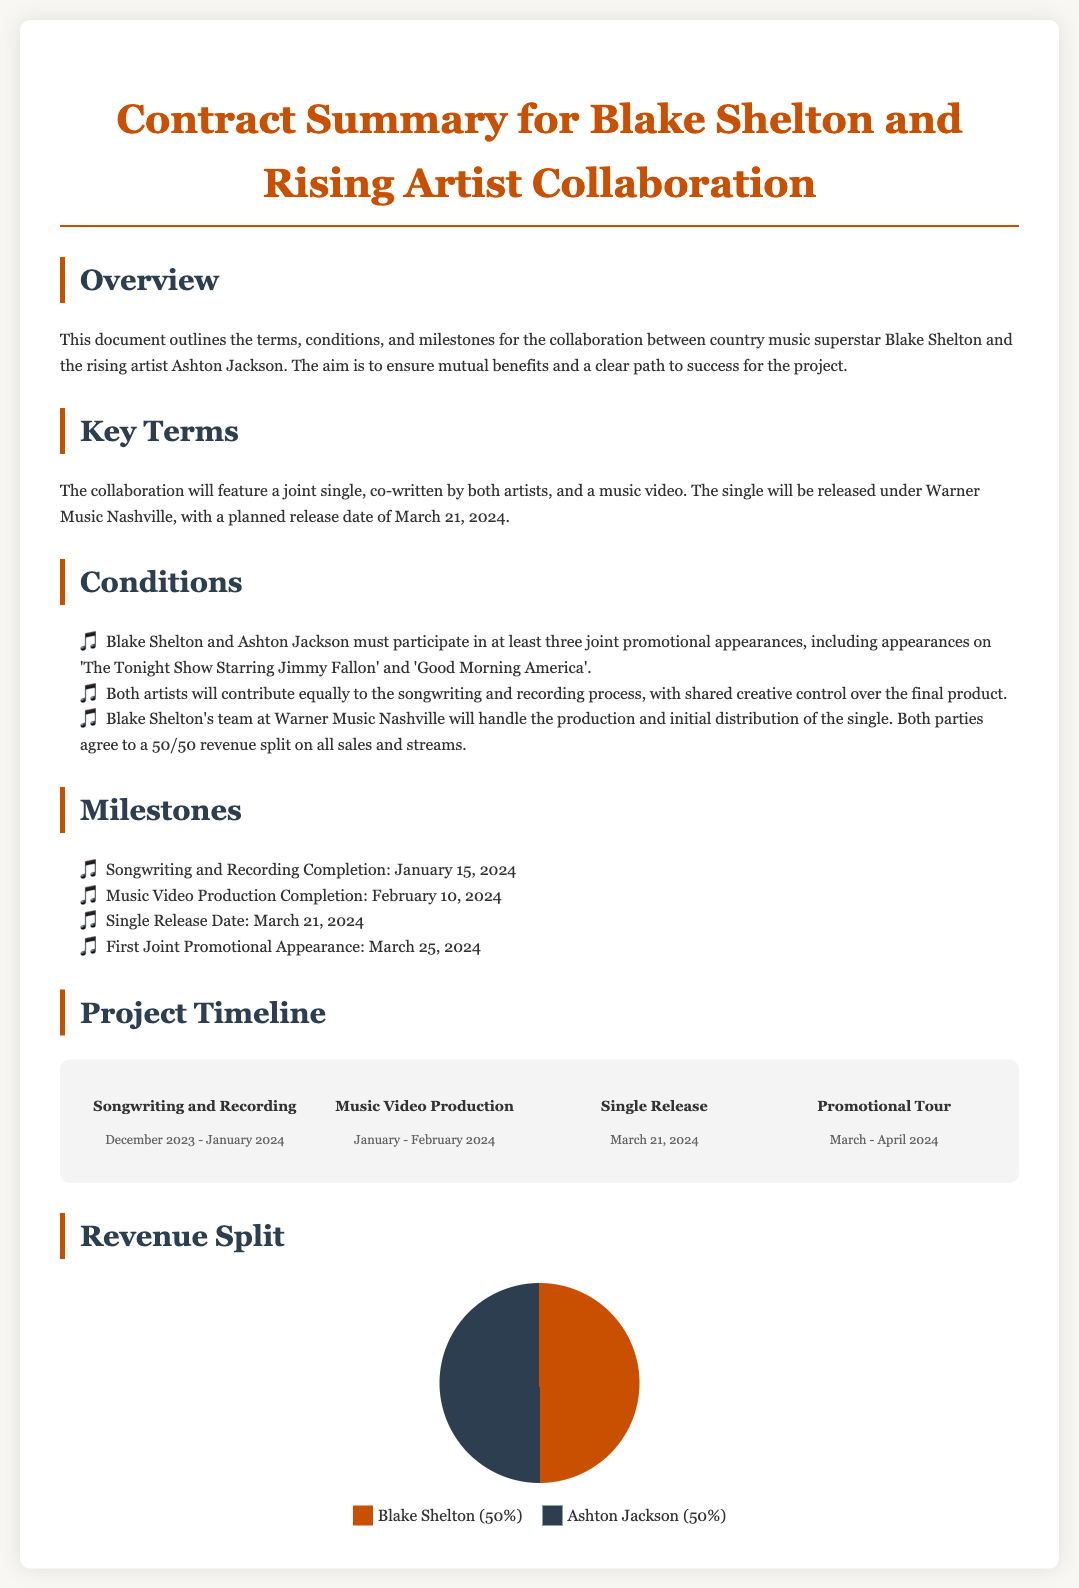What is the title of the document? The title prominently displayed at the top of the document is the main subject of the collaboration deal.
Answer: Contract Summary for Blake Shelton and Rising Artist Collaboration Who is the rising artist collaborating with Blake Shelton? The document specifically mentions the name of the rising artist involved in the collaboration.
Answer: Ashton Jackson When is the single scheduled for release? The planned release date for the single is explicitly stated in the document.
Answer: March 21, 2024 What is the completion date for songwriting and recording? The document outlines the milestone dates for various stages of the collaboration, including this specific one.
Answer: January 15, 2024 What is the revenue split between the artists? A visual representation in the document indicates how the revenue will be shared between the two artists.
Answer: 50/50 What are the two promotional appearances mentioned? The document lists specific shows where the artists must appear for promotion, prompting this query about them.
Answer: The Tonight Show Starring Jimmy Fallon and Good Morning America What does the timeline section describe? The timeline section of the document outlines key phases and their corresponding dates in the collaboration process.
Answer: Project Timeline How many joint promotional appearances must they participate in? This requirement is specified in the conditions section of the document to ensure visibility for the collaboration.
Answer: Three 